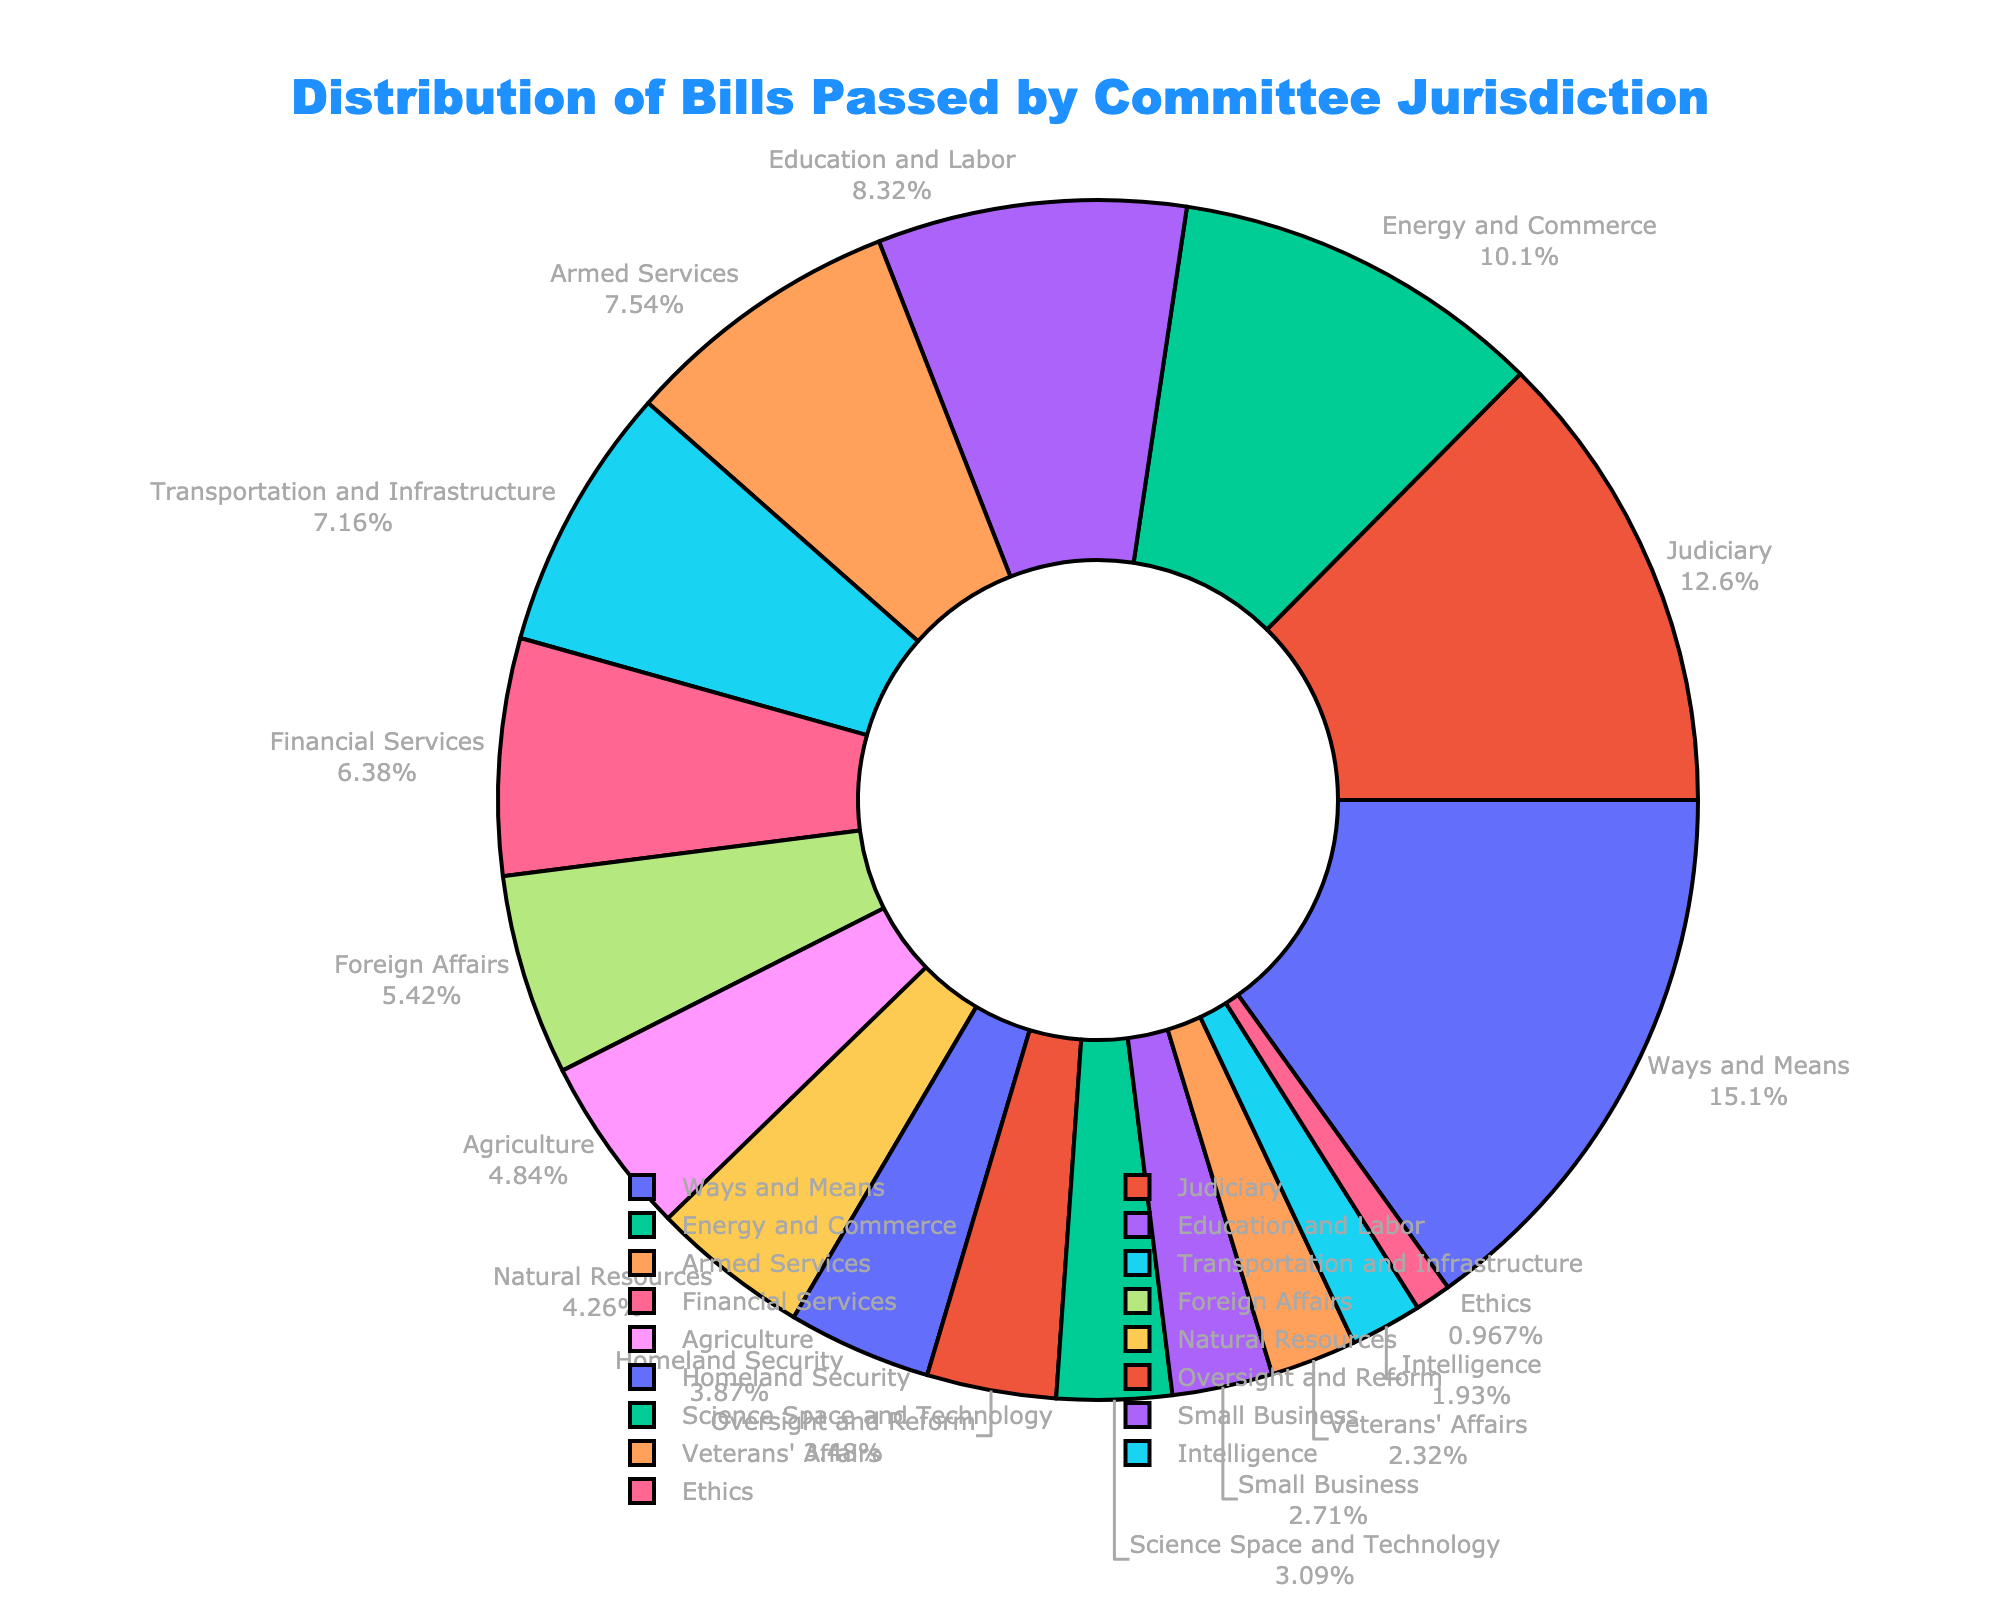What is the percentage of bills passed by the Ways and Means Committee? To find the percentage, locate the section of the pie chart labeled "Ways and Means" and identify the percentage value displayed next to it.
Answer: 17% Which committee passed more bills, Judiciary or Energy and Commerce? Compare the sections labeled "Judiciary" and "Energy and Commerce" to see which has a larger percentage value. Judiciary has 14% while Energy and Commerce has 11%.
Answer: Judiciary What is the combined percentage of bills passed by the Ways and Means and Judiciary committees? Add the individual percentages of the Ways and Means and Judiciary committees. Ways and Means has 17% and Judiciary has 14%, so 17% + 14% = 31%.
Answer: 31% How does the number of bills passed by the Education and Labor Committee compare to the Armed Services Committee? Compare the sections labeled "Education and Labor" and "Armed Services" to see which one has a larger percentage value. Education and Labor has 9% while Armed Services has 8%.
Answer: Education and Labor Which committee has the smallest percentage of bills passed? Find the smallest section of the pie chart. The section labeled "Ethics" has the smallest percentage.
Answer: Ethics What is the sum of the percentages of bills passed by Transportation and Infrastructure, Financial Services, and Foreign Affairs committees? Add the individual percentages of the Transportation and Infrastructure (8%), Financial Services (7%), and Foreign Affairs (6%) committees. So, 8% + 7% + 6% = 21%.
Answer: 21% How many more bills did the Ways and Means Committee pass compared to Homeland Security? First, identify the number of bills passed by the Ways and Means Committee (78) and Homeland Security (20). Then, subtract the smaller number from the larger one: 78 - 20.
Answer: 58 Compare the combined percentage of bills passed by committees in the lower half (Small Business, Veterans' Affairs, Intelligence, Ethics) to any single committee in the top three (Ways and Means, Judiciary, Energy and Commerce). Sum the percentages of the lower half committees: Small Business (3%), Veterans' Affairs (3%), Intelligence (2%), and Ethics (1%) which is 3% + 3% + 2% + 1% = 9%. Any single committee in the top three has more than 9% (Ways and Means has 17%, Judiciary has 14%, Energy and Commerce has 11%).
Answer: Top three have more Which committee's bills make up approximately 5% of the total? Look at the pie chart and find the committee with the section labeled around 5%. The Foreign Affairs committee fits this description at 6%.
Answer: Foreign Affairs 